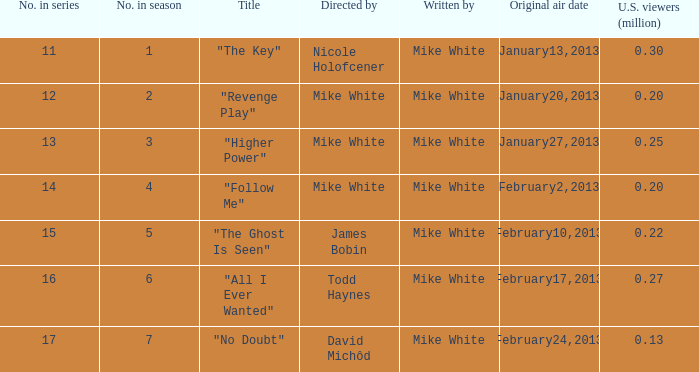How many episodes in the serie were title "the key" 1.0. 